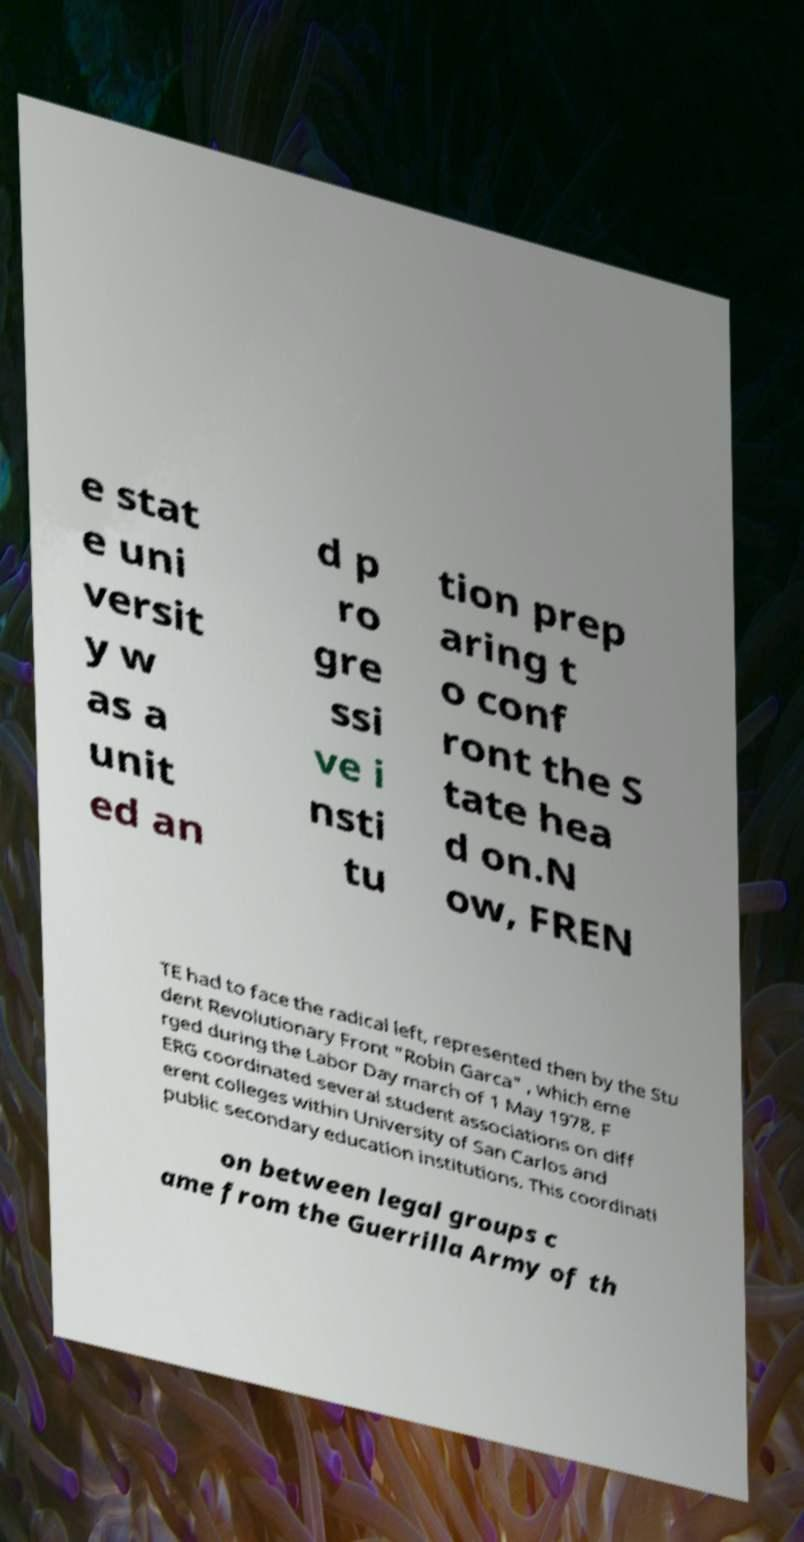Can you read and provide the text displayed in the image?This photo seems to have some interesting text. Can you extract and type it out for me? e stat e uni versit y w as a unit ed an d p ro gre ssi ve i nsti tu tion prep aring t o conf ront the S tate hea d on.N ow, FREN TE had to face the radical left, represented then by the Stu dent Revolutionary Front "Robin Garca" , which eme rged during the Labor Day march of 1 May 1978. F ERG coordinated several student associations on diff erent colleges within University of San Carlos and public secondary education institutions. This coordinati on between legal groups c ame from the Guerrilla Army of th 